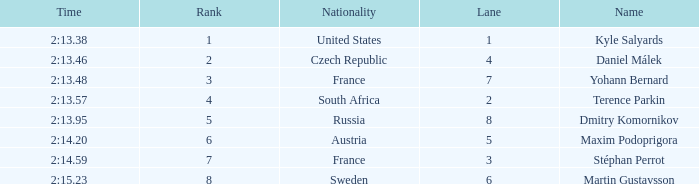What was Stéphan Perrot rank average? 7.0. 